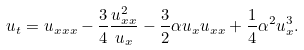<formula> <loc_0><loc_0><loc_500><loc_500>u _ { t } = u _ { x x x } - \frac { 3 } { 4 } \frac { u _ { x x } ^ { 2 } } { u _ { x } } - \frac { 3 } { 2 } \alpha u _ { x } u _ { x x } + \frac { 1 } { 4 } \alpha ^ { 2 } u _ { x } ^ { 3 } .</formula> 